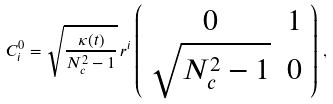<formula> <loc_0><loc_0><loc_500><loc_500>C ^ { 0 } _ { i } = \sqrt { \frac { \kappa ( t ) } { N _ { c } ^ { 2 } - 1 } } \, r ^ { i } \left ( \begin{array} { c c } 0 & 1 \\ \sqrt { N _ { c } ^ { 2 } - 1 } & 0 \end{array} \right ) \, ,</formula> 